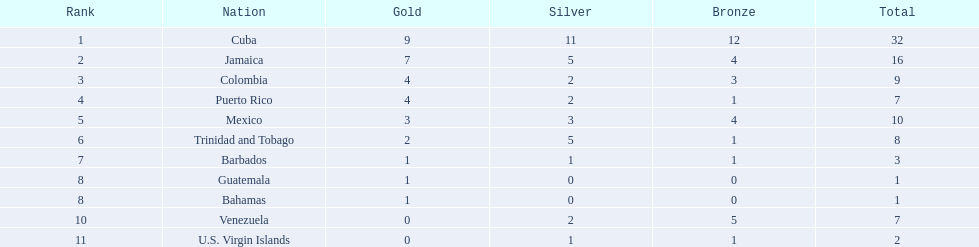Which teams have at exactly 4 gold medals? Colombia, Puerto Rico. Of those teams which has exactly 1 bronze medal? Puerto Rico. 